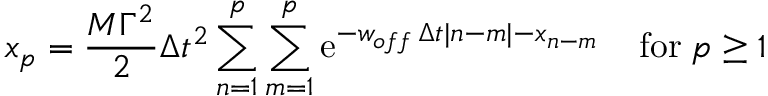<formula> <loc_0><loc_0><loc_500><loc_500>x _ { p } = { \frac { M \Gamma ^ { 2 } } { 2 } } \Delta t ^ { 2 } \sum _ { n = 1 } ^ { p } \sum _ { m = 1 } ^ { p } e ^ { - w _ { o f f } \, \Delta t | n - m | - x _ { n - m } } \, f o r \, p \geq 1</formula> 